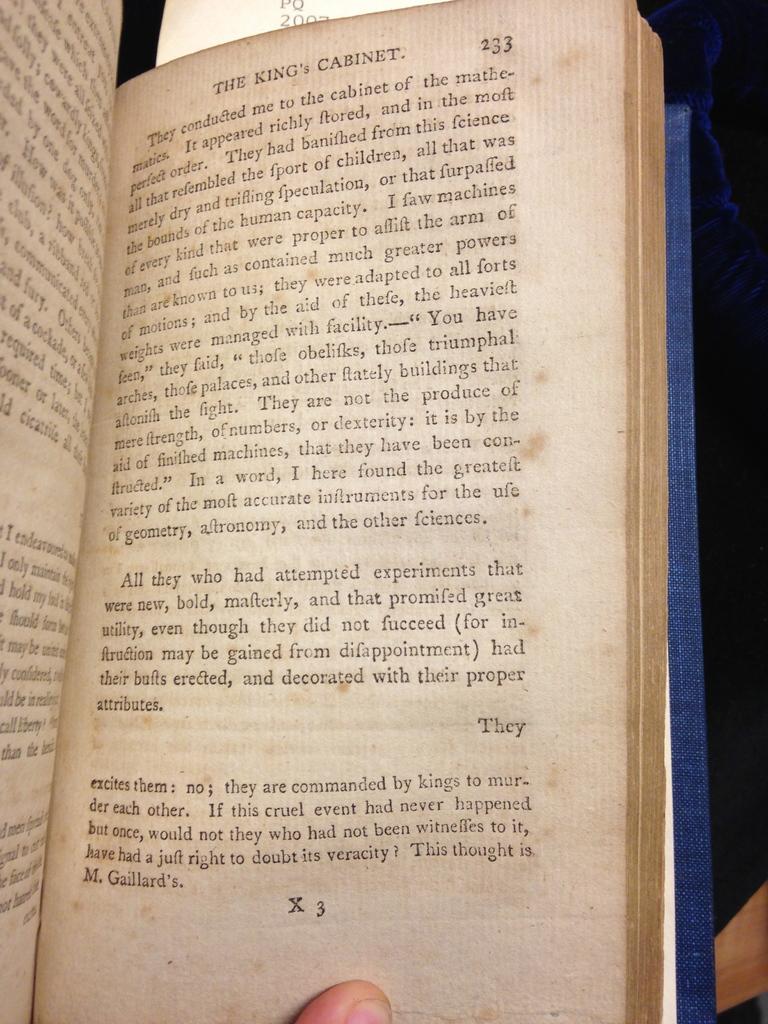What is the name of this book?
Ensure brevity in your answer.  The king's cabinet. 